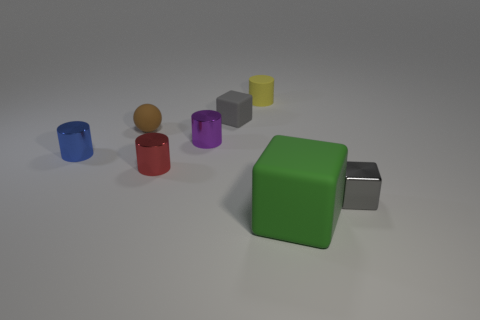Subtract all yellow blocks. Subtract all green cylinders. How many blocks are left? 3 Add 2 yellow metal things. How many objects exist? 10 Subtract all balls. How many objects are left? 7 Subtract all cylinders. Subtract all tiny red rubber things. How many objects are left? 4 Add 3 yellow rubber objects. How many yellow rubber objects are left? 4 Add 6 small blue shiny cylinders. How many small blue shiny cylinders exist? 7 Subtract 0 gray balls. How many objects are left? 8 